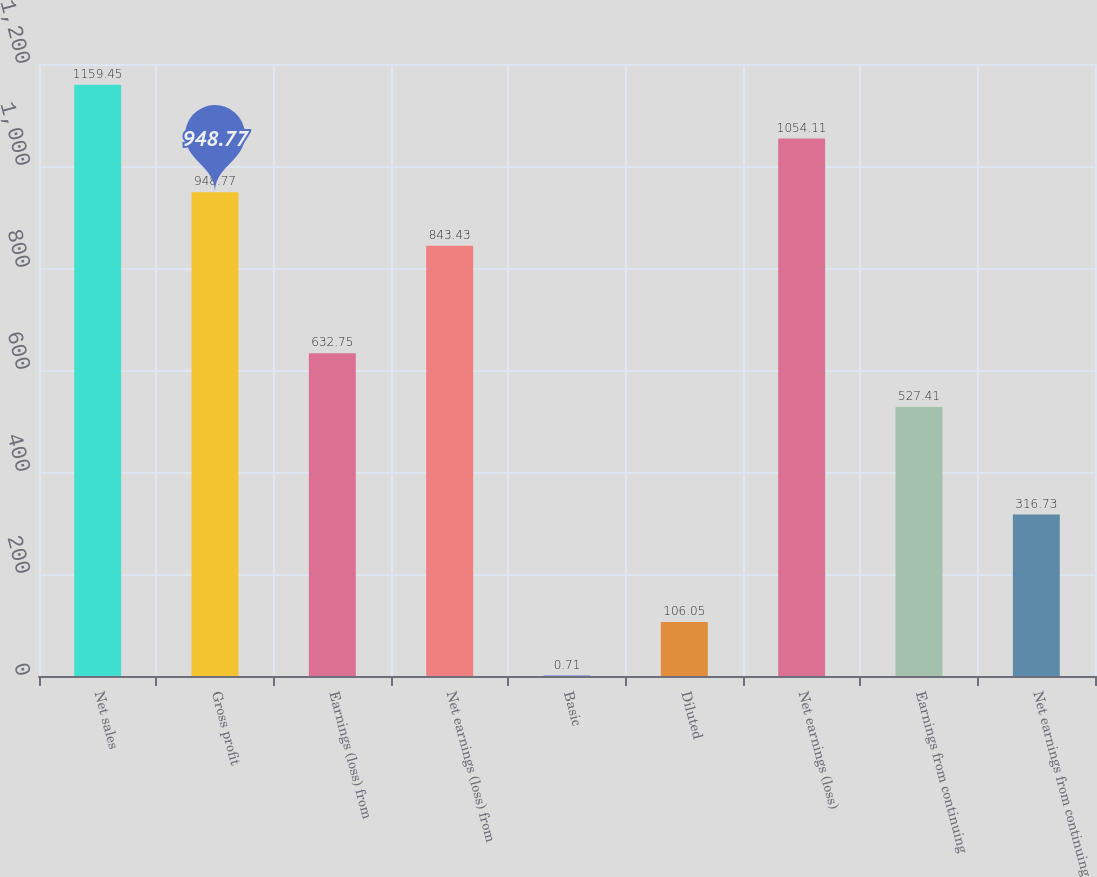Convert chart. <chart><loc_0><loc_0><loc_500><loc_500><bar_chart><fcel>Net sales<fcel>Gross profit<fcel>Earnings (loss) from<fcel>Net earnings (loss) from<fcel>Basic<fcel>Diluted<fcel>Net earnings (loss)<fcel>Earnings from continuing<fcel>Net earnings from continuing<nl><fcel>1159.45<fcel>948.77<fcel>632.75<fcel>843.43<fcel>0.71<fcel>106.05<fcel>1054.11<fcel>527.41<fcel>316.73<nl></chart> 